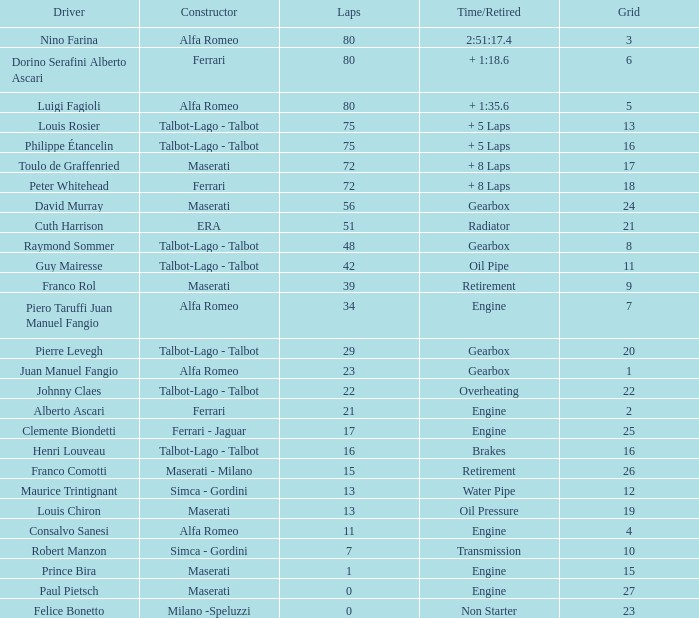What was the smallest grid for Prince bira? 15.0. 